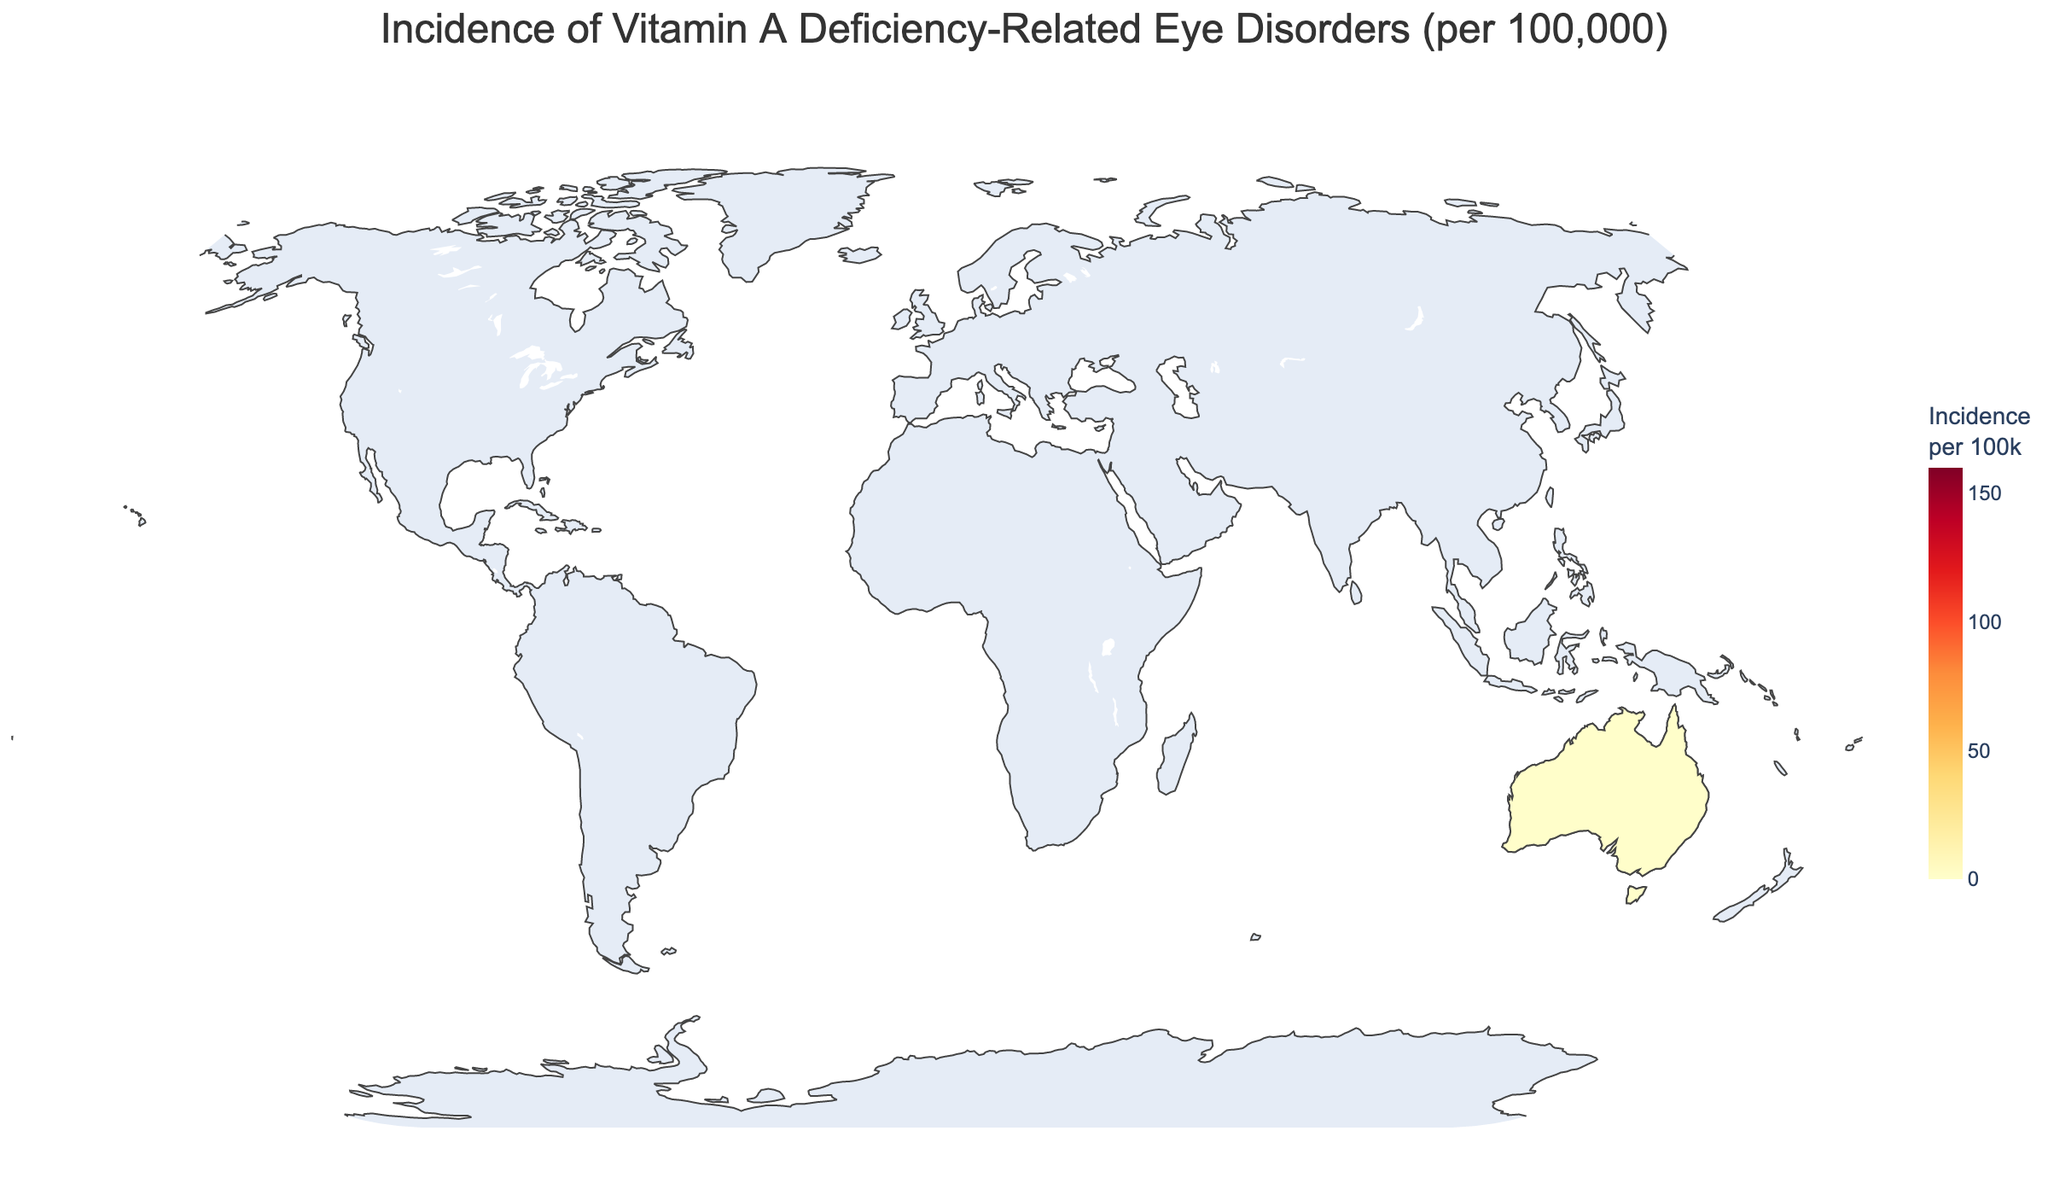What is the title of the plot? The title of the plot is usually displayed at the top of the figure to provide a clear summary of the visual data's content. The title can easily be read directly from the plot.
Answer: Incidence of Vitamin A Deficiency-Related Eye Disorders (per 100,000) Which region has the highest incidence of Vitamin A deficiency-related eye disorders? To determine the region with the highest incidence, refer to the color gradient scale. The darkest region represents the highest incidence. From the labeled regions on the map, Sub-Saharan Africa has the darkest color indicating the highest incidence.
Answer: Sub-Saharan Africa What are the incidence rates for North America and Australia and New Zealand, and which has a lower rate? Locate both regions on the map and refer to the corresponding shades on the color scale. North America and Australia and New Zealand have light shades close to the left end of the scale. North America has an incidence rate of 1.5, and Australia and New Zealand have an incidence rate of 0.9.
Answer: Australia and New Zealand How does the incidence rate in Central Asia compare to Southeast Asia? Compare the color shades or refer to the numerical values in the data. Central Asia has 41.2, and Southeast Asia has 45.6.
Answer: Southeast Asia has a slightly higher incidence rate List the top three regions with the highest incidence rates of Vitamin A deficiency-related eye disorders. By observing the figure and identifying the regions with the darkest shades, the top three are: 1) Sub-Saharan Africa, 2) South Asia, and 3) Southeast Asia.
Answer: Sub-Saharan Africa, South Asia, Southeast Asia What's the average incidence rate of the regions: Sub-Saharan Africa, South Asia, and Southeast Asia? Sum the incidence rates for these three regions and divide by the number of regions. (152.3 + 98.7 + 45.6) / 3 = 98.87
Answer: 98.87 Which regions have an incidence rate below 10 per 100,000? Identify regions with colors corresponding to the lowest end of the color scale and verify with the numerical values given. These regions are Western Europe, North America, and Australia and New Zealand.
Answer: Western Europe, North America, Australia and New Zealand What is the median incidence rate of the regions displayed on the map? Sort the incidence rates and find the middle value. Sorted rates: 0.9, 1.5, 2.3, 5.6, 7.8, 12.4, 18.9, 22.7, 32.1, 33.8, 41.2, 45.6, 98.7, 152.3. The middle value (8th in sorted order) is 22.7.
Answer: 22.7 